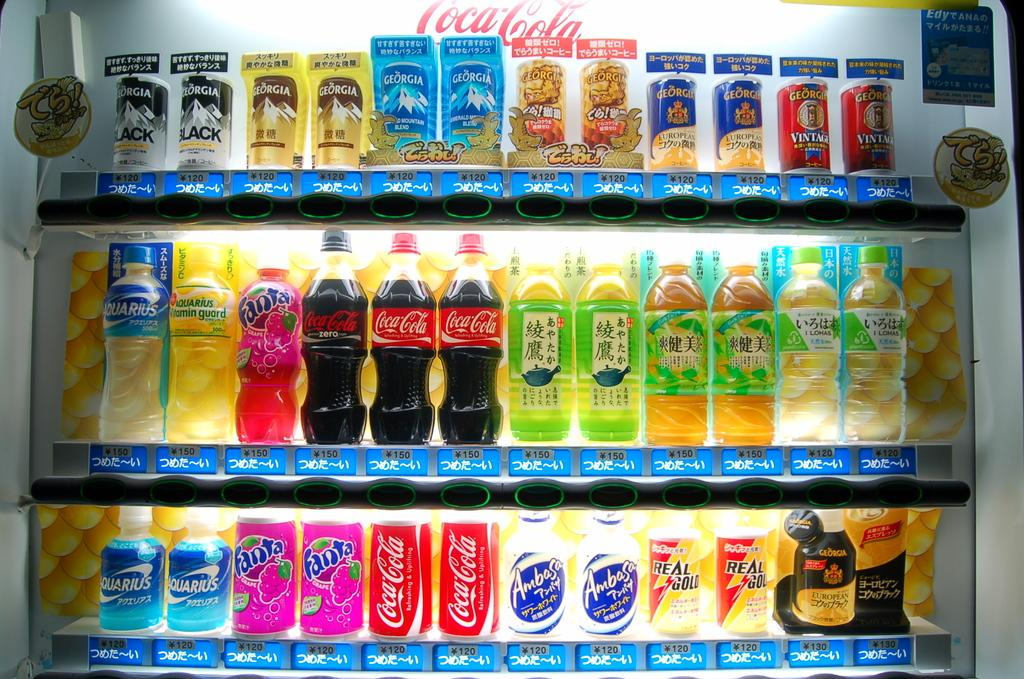What types of containers are visible in the image? There are bottles and tins in the image. How are the bottles and tins arranged in the image? The bottles and tins are in racks. Who is the creator of the mice in the image? There are no mice present in the image, so it is not possible to determine who created them. 